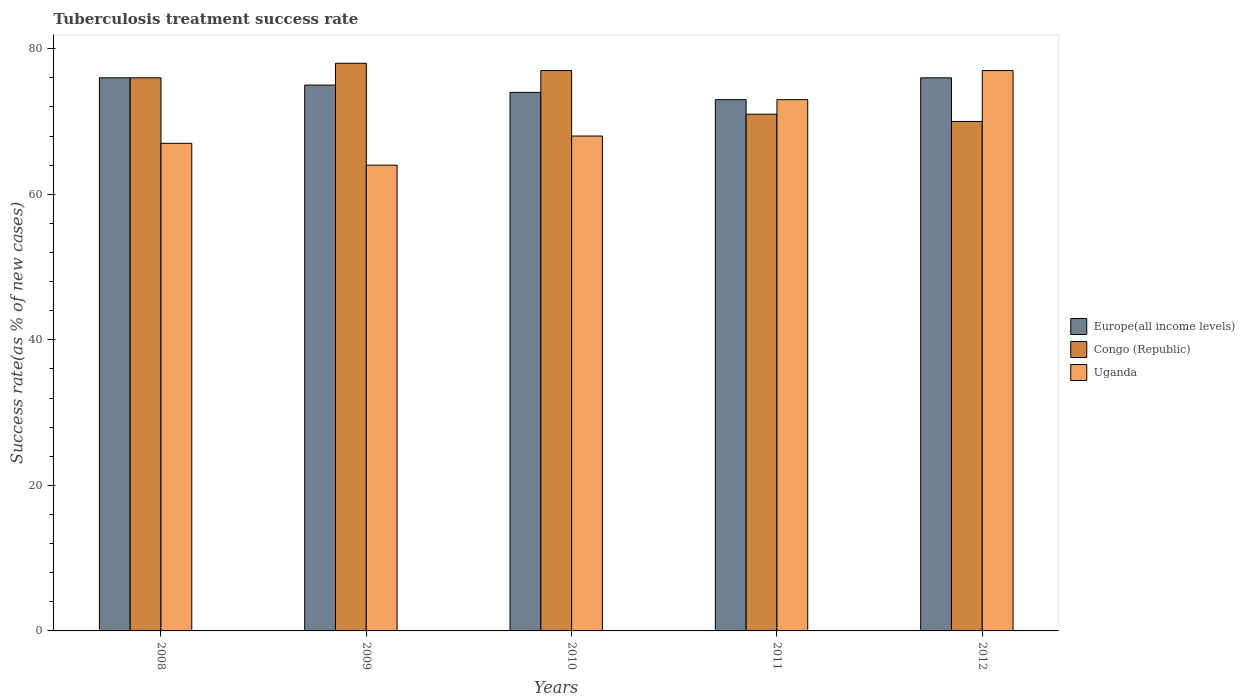Are the number of bars on each tick of the X-axis equal?
Your answer should be compact. Yes. How many bars are there on the 3rd tick from the left?
Offer a very short reply. 3. How many bars are there on the 1st tick from the right?
Make the answer very short. 3. In how many cases, is the number of bars for a given year not equal to the number of legend labels?
Give a very brief answer. 0. What is the tuberculosis treatment success rate in Congo (Republic) in 2012?
Offer a terse response. 70. Across all years, what is the maximum tuberculosis treatment success rate in Uganda?
Offer a very short reply. 77. Across all years, what is the minimum tuberculosis treatment success rate in Congo (Republic)?
Offer a terse response. 70. In which year was the tuberculosis treatment success rate in Uganda minimum?
Give a very brief answer. 2009. What is the total tuberculosis treatment success rate in Congo (Republic) in the graph?
Offer a terse response. 372. What is the difference between the tuberculosis treatment success rate in Congo (Republic) in 2010 and that in 2012?
Your answer should be compact. 7. What is the average tuberculosis treatment success rate in Uganda per year?
Provide a short and direct response. 69.8. In the year 2009, what is the difference between the tuberculosis treatment success rate in Uganda and tuberculosis treatment success rate in Congo (Republic)?
Make the answer very short. -14. In how many years, is the tuberculosis treatment success rate in Europe(all income levels) greater than 64 %?
Your answer should be compact. 5. What is the ratio of the tuberculosis treatment success rate in Congo (Republic) in 2008 to that in 2009?
Keep it short and to the point. 0.97. Is the tuberculosis treatment success rate in Uganda in 2009 less than that in 2010?
Your response must be concise. Yes. What is the difference between the highest and the second highest tuberculosis treatment success rate in Congo (Republic)?
Your answer should be compact. 1. What is the difference between the highest and the lowest tuberculosis treatment success rate in Europe(all income levels)?
Offer a terse response. 3. In how many years, is the tuberculosis treatment success rate in Uganda greater than the average tuberculosis treatment success rate in Uganda taken over all years?
Ensure brevity in your answer.  2. What does the 2nd bar from the left in 2009 represents?
Your response must be concise. Congo (Republic). What does the 3rd bar from the right in 2009 represents?
Give a very brief answer. Europe(all income levels). How many bars are there?
Offer a very short reply. 15. Are all the bars in the graph horizontal?
Your response must be concise. No. How many years are there in the graph?
Keep it short and to the point. 5. Does the graph contain grids?
Keep it short and to the point. No. How many legend labels are there?
Ensure brevity in your answer.  3. How are the legend labels stacked?
Offer a very short reply. Vertical. What is the title of the graph?
Keep it short and to the point. Tuberculosis treatment success rate. Does "Senegal" appear as one of the legend labels in the graph?
Your response must be concise. No. What is the label or title of the Y-axis?
Ensure brevity in your answer.  Success rate(as % of new cases). What is the Success rate(as % of new cases) in Congo (Republic) in 2009?
Offer a terse response. 78. What is the Success rate(as % of new cases) of Uganda in 2010?
Ensure brevity in your answer.  68. What is the Success rate(as % of new cases) in Congo (Republic) in 2011?
Your answer should be compact. 71. What is the Success rate(as % of new cases) in Uganda in 2011?
Your response must be concise. 73. What is the Success rate(as % of new cases) in Europe(all income levels) in 2012?
Your answer should be very brief. 76. What is the Success rate(as % of new cases) of Congo (Republic) in 2012?
Offer a very short reply. 70. Across all years, what is the maximum Success rate(as % of new cases) in Europe(all income levels)?
Provide a short and direct response. 76. Across all years, what is the minimum Success rate(as % of new cases) of Europe(all income levels)?
Your answer should be very brief. 73. Across all years, what is the minimum Success rate(as % of new cases) in Congo (Republic)?
Make the answer very short. 70. What is the total Success rate(as % of new cases) in Europe(all income levels) in the graph?
Keep it short and to the point. 374. What is the total Success rate(as % of new cases) in Congo (Republic) in the graph?
Provide a succinct answer. 372. What is the total Success rate(as % of new cases) of Uganda in the graph?
Provide a succinct answer. 349. What is the difference between the Success rate(as % of new cases) of Europe(all income levels) in 2008 and that in 2009?
Your answer should be very brief. 1. What is the difference between the Success rate(as % of new cases) of Congo (Republic) in 2008 and that in 2009?
Provide a succinct answer. -2. What is the difference between the Success rate(as % of new cases) in Uganda in 2008 and that in 2009?
Keep it short and to the point. 3. What is the difference between the Success rate(as % of new cases) of Europe(all income levels) in 2008 and that in 2010?
Your answer should be compact. 2. What is the difference between the Success rate(as % of new cases) of Congo (Republic) in 2008 and that in 2010?
Keep it short and to the point. -1. What is the difference between the Success rate(as % of new cases) in Europe(all income levels) in 2008 and that in 2011?
Offer a terse response. 3. What is the difference between the Success rate(as % of new cases) of Congo (Republic) in 2008 and that in 2011?
Make the answer very short. 5. What is the difference between the Success rate(as % of new cases) in Uganda in 2008 and that in 2011?
Ensure brevity in your answer.  -6. What is the difference between the Success rate(as % of new cases) of Uganda in 2008 and that in 2012?
Provide a short and direct response. -10. What is the difference between the Success rate(as % of new cases) of Congo (Republic) in 2009 and that in 2010?
Provide a succinct answer. 1. What is the difference between the Success rate(as % of new cases) in Uganda in 2009 and that in 2010?
Your response must be concise. -4. What is the difference between the Success rate(as % of new cases) of Congo (Republic) in 2009 and that in 2011?
Your answer should be compact. 7. What is the difference between the Success rate(as % of new cases) of Uganda in 2009 and that in 2011?
Provide a short and direct response. -9. What is the difference between the Success rate(as % of new cases) in Congo (Republic) in 2009 and that in 2012?
Offer a terse response. 8. What is the difference between the Success rate(as % of new cases) of Congo (Republic) in 2010 and that in 2011?
Make the answer very short. 6. What is the difference between the Success rate(as % of new cases) of Uganda in 2010 and that in 2011?
Offer a terse response. -5. What is the difference between the Success rate(as % of new cases) of Europe(all income levels) in 2010 and that in 2012?
Offer a terse response. -2. What is the difference between the Success rate(as % of new cases) in Uganda in 2010 and that in 2012?
Keep it short and to the point. -9. What is the difference between the Success rate(as % of new cases) of Congo (Republic) in 2011 and that in 2012?
Give a very brief answer. 1. What is the difference between the Success rate(as % of new cases) of Uganda in 2011 and that in 2012?
Provide a short and direct response. -4. What is the difference between the Success rate(as % of new cases) in Europe(all income levels) in 2008 and the Success rate(as % of new cases) in Congo (Republic) in 2009?
Give a very brief answer. -2. What is the difference between the Success rate(as % of new cases) of Europe(all income levels) in 2008 and the Success rate(as % of new cases) of Uganda in 2009?
Provide a succinct answer. 12. What is the difference between the Success rate(as % of new cases) in Europe(all income levels) in 2008 and the Success rate(as % of new cases) in Uganda in 2010?
Offer a terse response. 8. What is the difference between the Success rate(as % of new cases) in Congo (Republic) in 2008 and the Success rate(as % of new cases) in Uganda in 2010?
Your answer should be compact. 8. What is the difference between the Success rate(as % of new cases) in Europe(all income levels) in 2009 and the Success rate(as % of new cases) in Congo (Republic) in 2010?
Your answer should be very brief. -2. What is the difference between the Success rate(as % of new cases) of Europe(all income levels) in 2009 and the Success rate(as % of new cases) of Uganda in 2010?
Offer a very short reply. 7. What is the difference between the Success rate(as % of new cases) of Congo (Republic) in 2009 and the Success rate(as % of new cases) of Uganda in 2010?
Provide a short and direct response. 10. What is the difference between the Success rate(as % of new cases) of Europe(all income levels) in 2009 and the Success rate(as % of new cases) of Uganda in 2011?
Provide a succinct answer. 2. What is the difference between the Success rate(as % of new cases) in Congo (Republic) in 2009 and the Success rate(as % of new cases) in Uganda in 2011?
Keep it short and to the point. 5. What is the difference between the Success rate(as % of new cases) in Congo (Republic) in 2009 and the Success rate(as % of new cases) in Uganda in 2012?
Your response must be concise. 1. What is the difference between the Success rate(as % of new cases) of Europe(all income levels) in 2010 and the Success rate(as % of new cases) of Congo (Republic) in 2011?
Your response must be concise. 3. What is the difference between the Success rate(as % of new cases) in Congo (Republic) in 2010 and the Success rate(as % of new cases) in Uganda in 2011?
Your answer should be compact. 4. What is the difference between the Success rate(as % of new cases) of Europe(all income levels) in 2010 and the Success rate(as % of new cases) of Congo (Republic) in 2012?
Your response must be concise. 4. What is the difference between the Success rate(as % of new cases) in Europe(all income levels) in 2011 and the Success rate(as % of new cases) in Uganda in 2012?
Ensure brevity in your answer.  -4. What is the average Success rate(as % of new cases) of Europe(all income levels) per year?
Make the answer very short. 74.8. What is the average Success rate(as % of new cases) of Congo (Republic) per year?
Keep it short and to the point. 74.4. What is the average Success rate(as % of new cases) in Uganda per year?
Provide a succinct answer. 69.8. In the year 2008, what is the difference between the Success rate(as % of new cases) of Congo (Republic) and Success rate(as % of new cases) of Uganda?
Ensure brevity in your answer.  9. In the year 2010, what is the difference between the Success rate(as % of new cases) in Europe(all income levels) and Success rate(as % of new cases) in Congo (Republic)?
Offer a terse response. -3. In the year 2010, what is the difference between the Success rate(as % of new cases) in Congo (Republic) and Success rate(as % of new cases) in Uganda?
Keep it short and to the point. 9. In the year 2011, what is the difference between the Success rate(as % of new cases) of Europe(all income levels) and Success rate(as % of new cases) of Uganda?
Ensure brevity in your answer.  0. In the year 2011, what is the difference between the Success rate(as % of new cases) in Congo (Republic) and Success rate(as % of new cases) in Uganda?
Make the answer very short. -2. In the year 2012, what is the difference between the Success rate(as % of new cases) in Europe(all income levels) and Success rate(as % of new cases) in Congo (Republic)?
Provide a short and direct response. 6. What is the ratio of the Success rate(as % of new cases) of Europe(all income levels) in 2008 to that in 2009?
Your answer should be compact. 1.01. What is the ratio of the Success rate(as % of new cases) in Congo (Republic) in 2008 to that in 2009?
Offer a terse response. 0.97. What is the ratio of the Success rate(as % of new cases) of Uganda in 2008 to that in 2009?
Your response must be concise. 1.05. What is the ratio of the Success rate(as % of new cases) of Europe(all income levels) in 2008 to that in 2010?
Your answer should be very brief. 1.03. What is the ratio of the Success rate(as % of new cases) in Europe(all income levels) in 2008 to that in 2011?
Ensure brevity in your answer.  1.04. What is the ratio of the Success rate(as % of new cases) in Congo (Republic) in 2008 to that in 2011?
Provide a succinct answer. 1.07. What is the ratio of the Success rate(as % of new cases) of Uganda in 2008 to that in 2011?
Provide a succinct answer. 0.92. What is the ratio of the Success rate(as % of new cases) of Europe(all income levels) in 2008 to that in 2012?
Give a very brief answer. 1. What is the ratio of the Success rate(as % of new cases) in Congo (Republic) in 2008 to that in 2012?
Give a very brief answer. 1.09. What is the ratio of the Success rate(as % of new cases) in Uganda in 2008 to that in 2012?
Your response must be concise. 0.87. What is the ratio of the Success rate(as % of new cases) in Europe(all income levels) in 2009 to that in 2010?
Your answer should be very brief. 1.01. What is the ratio of the Success rate(as % of new cases) of Congo (Republic) in 2009 to that in 2010?
Keep it short and to the point. 1.01. What is the ratio of the Success rate(as % of new cases) of Europe(all income levels) in 2009 to that in 2011?
Your answer should be compact. 1.03. What is the ratio of the Success rate(as % of new cases) in Congo (Republic) in 2009 to that in 2011?
Your answer should be very brief. 1.1. What is the ratio of the Success rate(as % of new cases) of Uganda in 2009 to that in 2011?
Your answer should be compact. 0.88. What is the ratio of the Success rate(as % of new cases) in Europe(all income levels) in 2009 to that in 2012?
Ensure brevity in your answer.  0.99. What is the ratio of the Success rate(as % of new cases) in Congo (Republic) in 2009 to that in 2012?
Provide a short and direct response. 1.11. What is the ratio of the Success rate(as % of new cases) in Uganda in 2009 to that in 2012?
Your answer should be compact. 0.83. What is the ratio of the Success rate(as % of new cases) in Europe(all income levels) in 2010 to that in 2011?
Your answer should be compact. 1.01. What is the ratio of the Success rate(as % of new cases) in Congo (Republic) in 2010 to that in 2011?
Your answer should be compact. 1.08. What is the ratio of the Success rate(as % of new cases) of Uganda in 2010 to that in 2011?
Give a very brief answer. 0.93. What is the ratio of the Success rate(as % of new cases) of Europe(all income levels) in 2010 to that in 2012?
Ensure brevity in your answer.  0.97. What is the ratio of the Success rate(as % of new cases) in Congo (Republic) in 2010 to that in 2012?
Give a very brief answer. 1.1. What is the ratio of the Success rate(as % of new cases) in Uganda in 2010 to that in 2012?
Give a very brief answer. 0.88. What is the ratio of the Success rate(as % of new cases) in Europe(all income levels) in 2011 to that in 2012?
Your response must be concise. 0.96. What is the ratio of the Success rate(as % of new cases) of Congo (Republic) in 2011 to that in 2012?
Make the answer very short. 1.01. What is the ratio of the Success rate(as % of new cases) of Uganda in 2011 to that in 2012?
Ensure brevity in your answer.  0.95. What is the difference between the highest and the second highest Success rate(as % of new cases) of Congo (Republic)?
Provide a short and direct response. 1. What is the difference between the highest and the lowest Success rate(as % of new cases) in Europe(all income levels)?
Your answer should be compact. 3. What is the difference between the highest and the lowest Success rate(as % of new cases) in Congo (Republic)?
Your response must be concise. 8. 